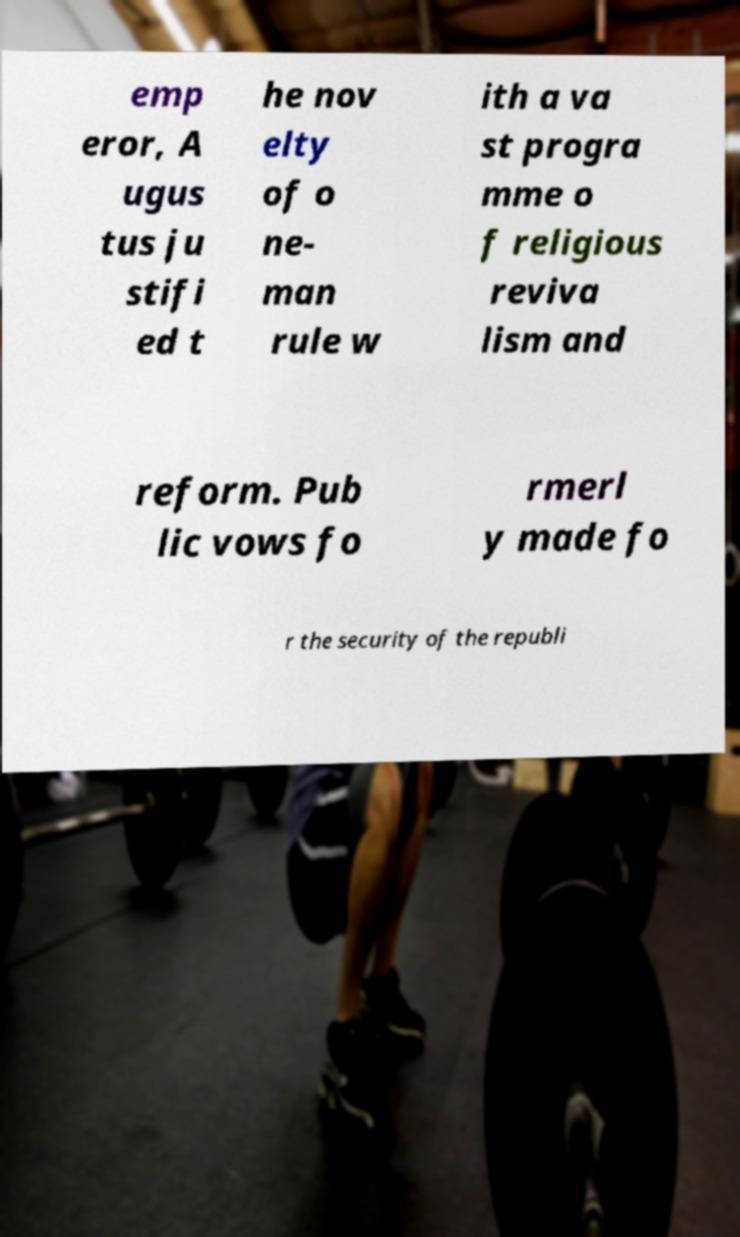Please read and relay the text visible in this image. What does it say? emp eror, A ugus tus ju stifi ed t he nov elty of o ne- man rule w ith a va st progra mme o f religious reviva lism and reform. Pub lic vows fo rmerl y made fo r the security of the republi 